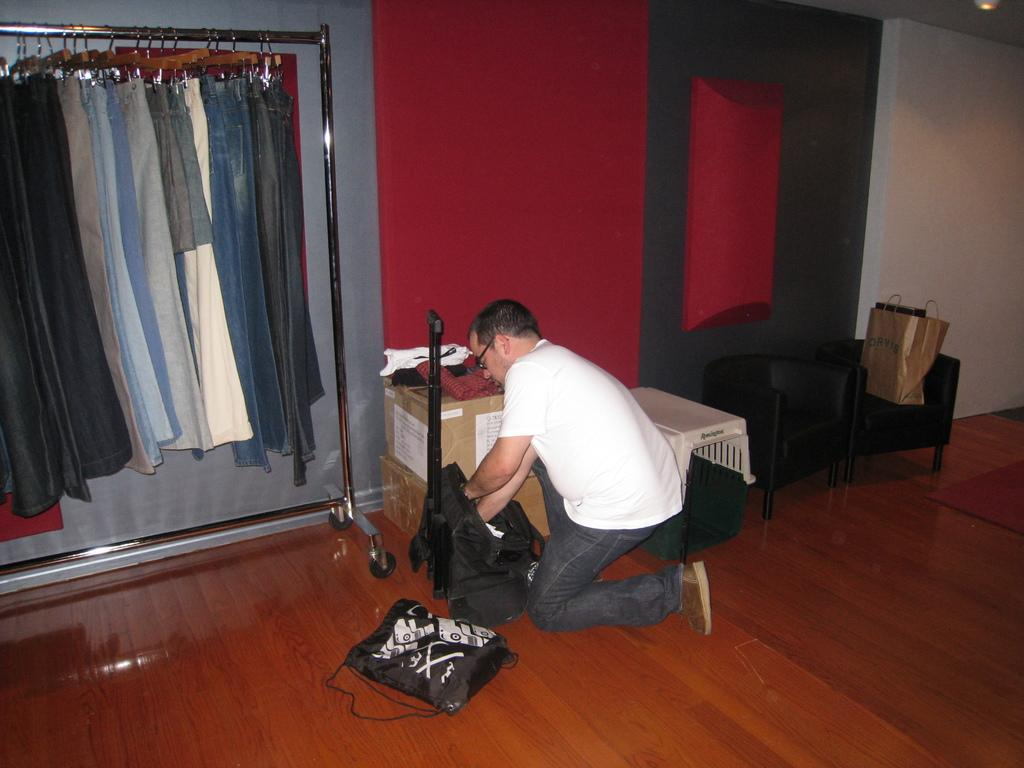What is the man in the image doing? The man is standing on his knees and packing a bag. What is located beside the man? There is a bag beside the man. What type of objects can be seen in the image? There are cotton boxes and chairs in the image. What can be seen in the background of the image? There is a wall and clothes hanging on a pole in the background. How many twigs are visible in the image? There are no twigs present in the image. What is the police doing in the image? There is no police presence in the image. 